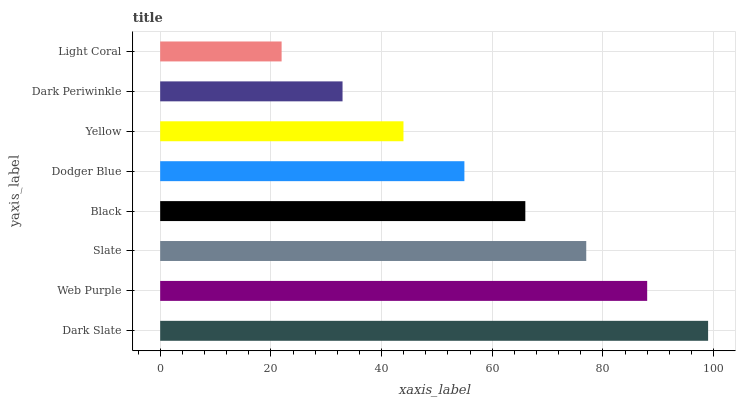Is Light Coral the minimum?
Answer yes or no. Yes. Is Dark Slate the maximum?
Answer yes or no. Yes. Is Web Purple the minimum?
Answer yes or no. No. Is Web Purple the maximum?
Answer yes or no. No. Is Dark Slate greater than Web Purple?
Answer yes or no. Yes. Is Web Purple less than Dark Slate?
Answer yes or no. Yes. Is Web Purple greater than Dark Slate?
Answer yes or no. No. Is Dark Slate less than Web Purple?
Answer yes or no. No. Is Black the high median?
Answer yes or no. Yes. Is Dodger Blue the low median?
Answer yes or no. Yes. Is Dark Periwinkle the high median?
Answer yes or no. No. Is Web Purple the low median?
Answer yes or no. No. 